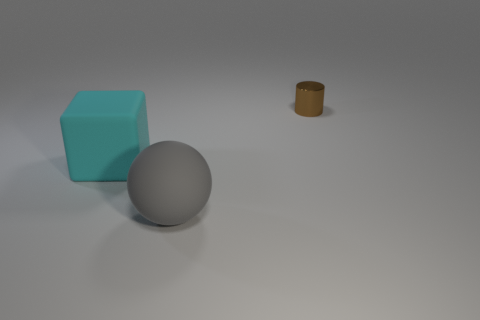Add 1 small purple metal objects. How many objects exist? 4 Subtract all cylinders. How many objects are left? 2 Add 1 tiny yellow metal spheres. How many tiny yellow metal spheres exist? 1 Subtract 1 gray balls. How many objects are left? 2 Subtract all large blue matte blocks. Subtract all tiny brown metal objects. How many objects are left? 2 Add 2 blocks. How many blocks are left? 3 